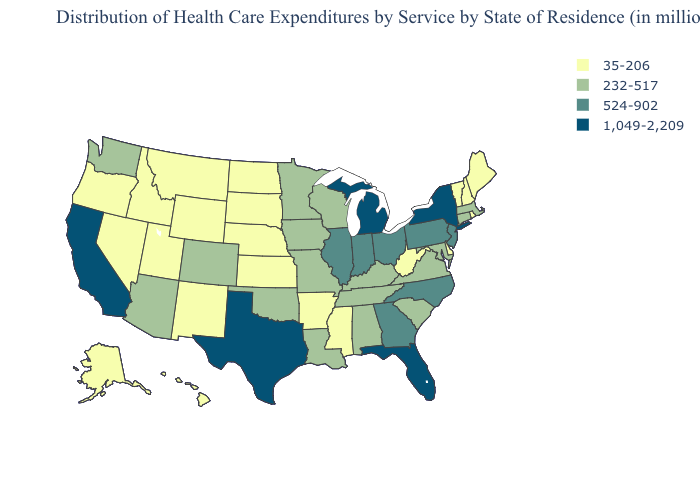Name the states that have a value in the range 524-902?
Keep it brief. Georgia, Illinois, Indiana, New Jersey, North Carolina, Ohio, Pennsylvania. Name the states that have a value in the range 35-206?
Quick response, please. Alaska, Arkansas, Delaware, Hawaii, Idaho, Kansas, Maine, Mississippi, Montana, Nebraska, Nevada, New Hampshire, New Mexico, North Dakota, Oregon, Rhode Island, South Dakota, Utah, Vermont, West Virginia, Wyoming. What is the value of Arizona?
Write a very short answer. 232-517. Does New Jersey have a higher value than New York?
Be succinct. No. Name the states that have a value in the range 524-902?
Give a very brief answer. Georgia, Illinois, Indiana, New Jersey, North Carolina, Ohio, Pennsylvania. What is the value of Oregon?
Give a very brief answer. 35-206. Which states have the lowest value in the USA?
Concise answer only. Alaska, Arkansas, Delaware, Hawaii, Idaho, Kansas, Maine, Mississippi, Montana, Nebraska, Nevada, New Hampshire, New Mexico, North Dakota, Oregon, Rhode Island, South Dakota, Utah, Vermont, West Virginia, Wyoming. Among the states that border Illinois , does Indiana have the lowest value?
Give a very brief answer. No. What is the value of Colorado?
Write a very short answer. 232-517. What is the value of Indiana?
Give a very brief answer. 524-902. Name the states that have a value in the range 1,049-2,209?
Concise answer only. California, Florida, Michigan, New York, Texas. Name the states that have a value in the range 1,049-2,209?
Answer briefly. California, Florida, Michigan, New York, Texas. What is the lowest value in the USA?
Write a very short answer. 35-206. Name the states that have a value in the range 524-902?
Write a very short answer. Georgia, Illinois, Indiana, New Jersey, North Carolina, Ohio, Pennsylvania. Is the legend a continuous bar?
Answer briefly. No. 